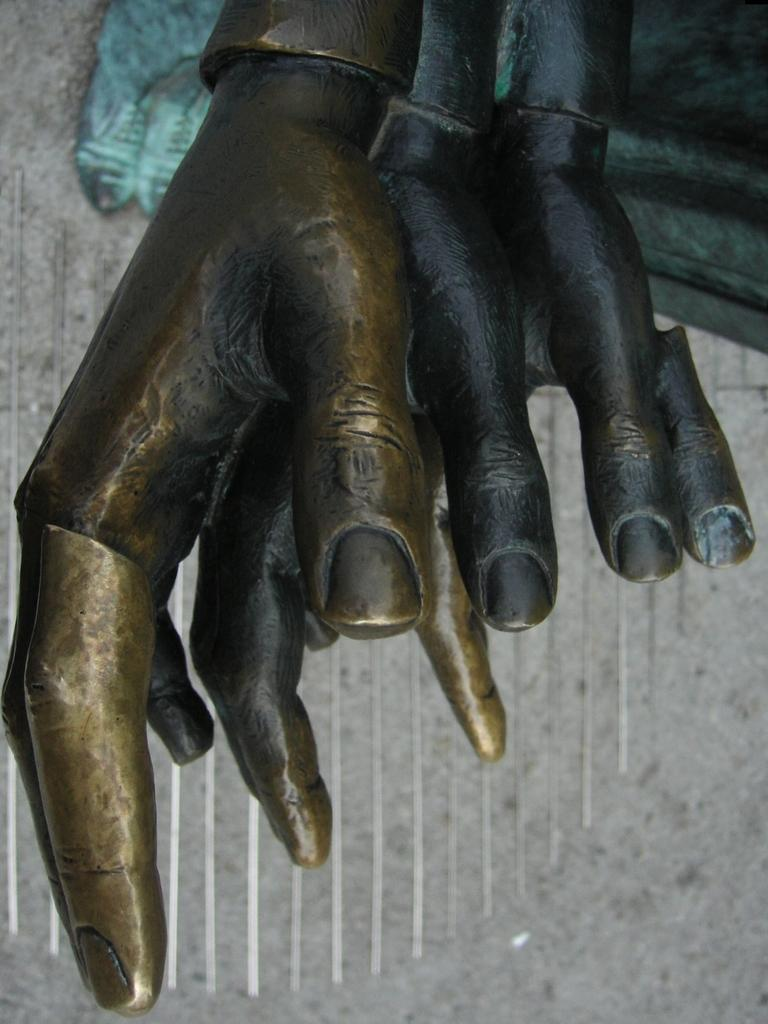What is the main subject of the image? There is a sculpture in the image. What type of oatmeal is being served on the island in the image? There is no oatmeal or island present in the image; it features a sculpture. What kind of insurance policy is being discussed in the image? There is no discussion of insurance in the image; it features a sculpture. 